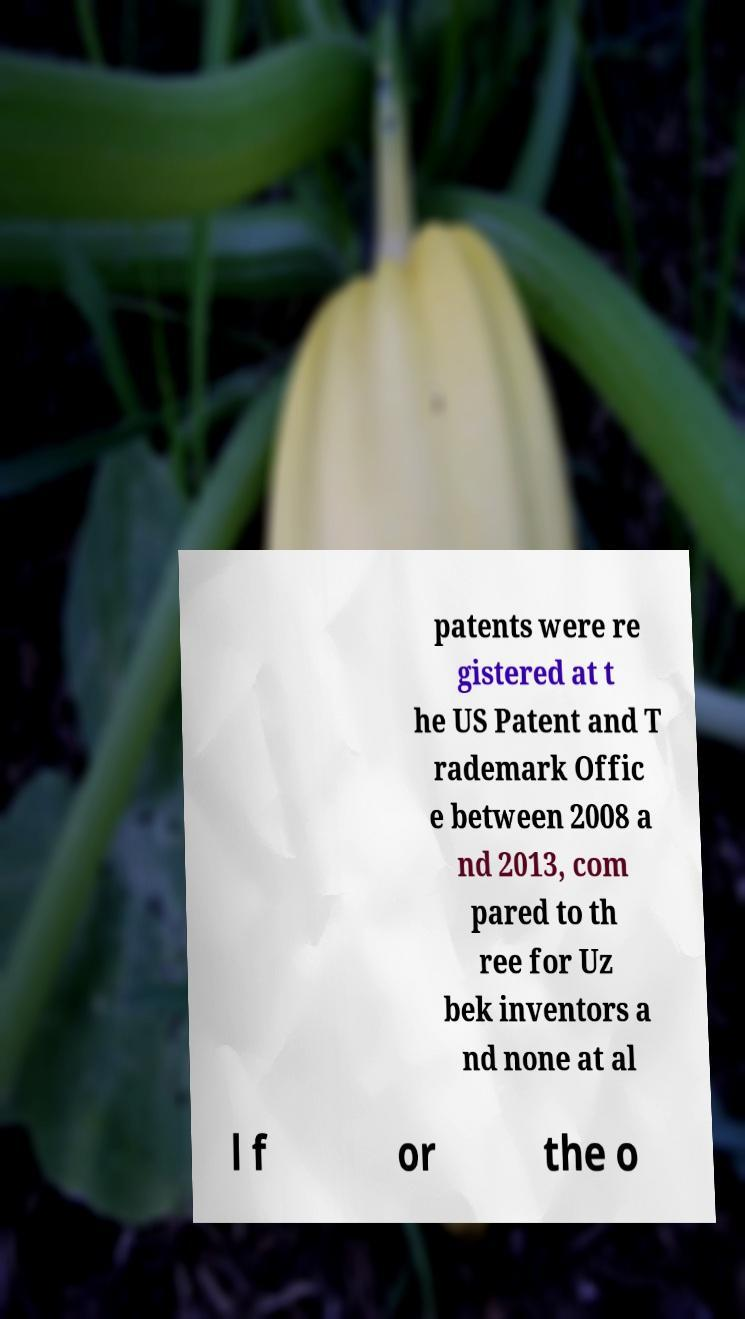There's text embedded in this image that I need extracted. Can you transcribe it verbatim? patents were re gistered at t he US Patent and T rademark Offic e between 2008 a nd 2013, com pared to th ree for Uz bek inventors a nd none at al l f or the o 